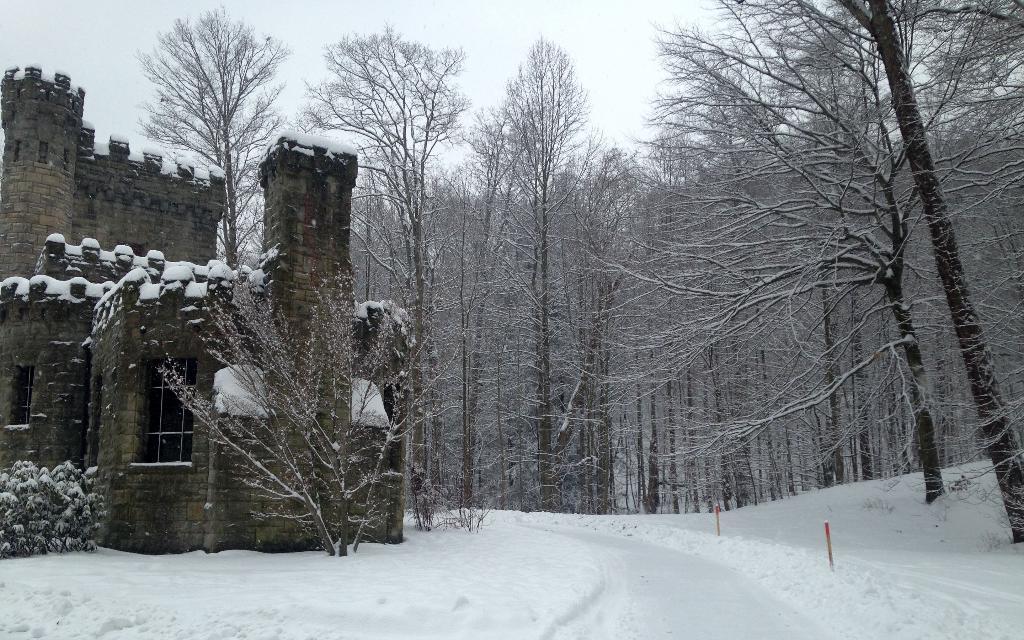Please provide a concise description of this image. In this picture we can see some tree, there is a house and in the background of the picture there are some trees. 